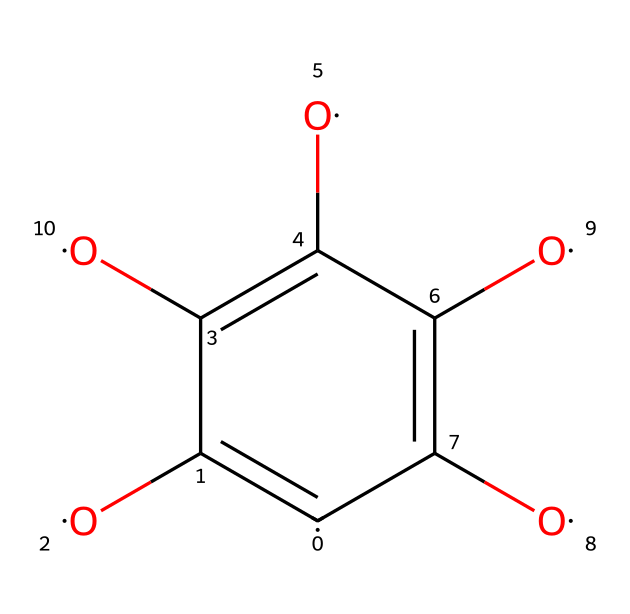What is the molecular formula of graphene oxide represented in the SMILES? By analyzing the SMILES representation, we identify the atoms present: there are 6 carbon atoms (C) and 4 oxygen atoms (O). This leads to the formula C6O4.
Answer: C6O4 How many oxygen atoms are present in the structure? The SMILES indicates four instances of the oxygen atom (O).
Answer: 4 What functional groups are present in this molecule? The presence of multiple -OH (hydroxyl) groups can be inferred from the -O and the connectivity in the SMILES. Additionally, the =O indicates carbonyl groups.
Answer: hydroxyl, carbonyl Is the molecule saturated or unsaturated? The presence of double bonds (indicated by the = in the SMILES) suggests that the molecule is unsaturated.
Answer: unsaturated What is the significance of graphene oxide in flexible electronic displays? Due to its high conductivity, mechanical strength, and flexibility, graphene oxide is used for creating lightweight, flexible electronic components in displays.
Answer: high conductivity, flexibility Which type of bonding is dominant in graphene oxide? The presence of covalent bonds is indicated by the connections between carbon and oxygen atoms throughout the structure.
Answer: covalent 